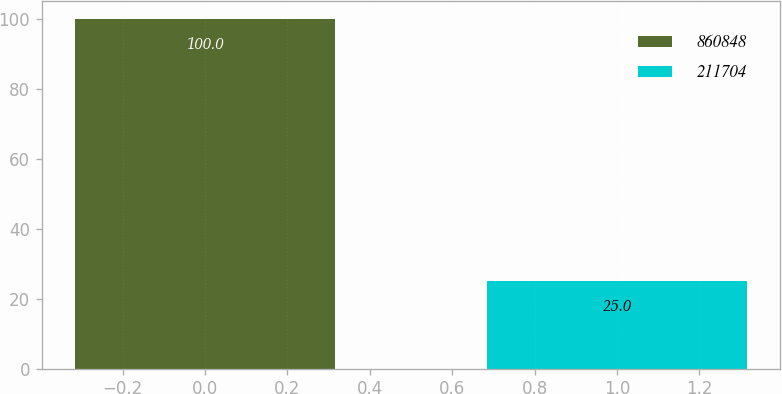<chart> <loc_0><loc_0><loc_500><loc_500><bar_chart><fcel>860848<fcel>211704<nl><fcel>100<fcel>25<nl></chart> 